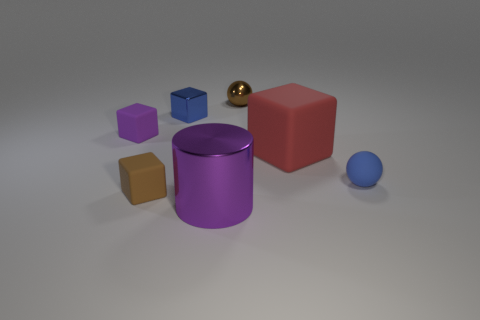Subtract 1 blocks. How many blocks are left? 3 Add 2 small blue things. How many objects exist? 9 Subtract all green blocks. Subtract all yellow cylinders. How many blocks are left? 4 Subtract all spheres. How many objects are left? 5 Add 5 blue cubes. How many blue cubes exist? 6 Subtract 0 yellow spheres. How many objects are left? 7 Subtract all big purple shiny cylinders. Subtract all large purple rubber things. How many objects are left? 6 Add 5 small brown metal spheres. How many small brown metal spheres are left? 6 